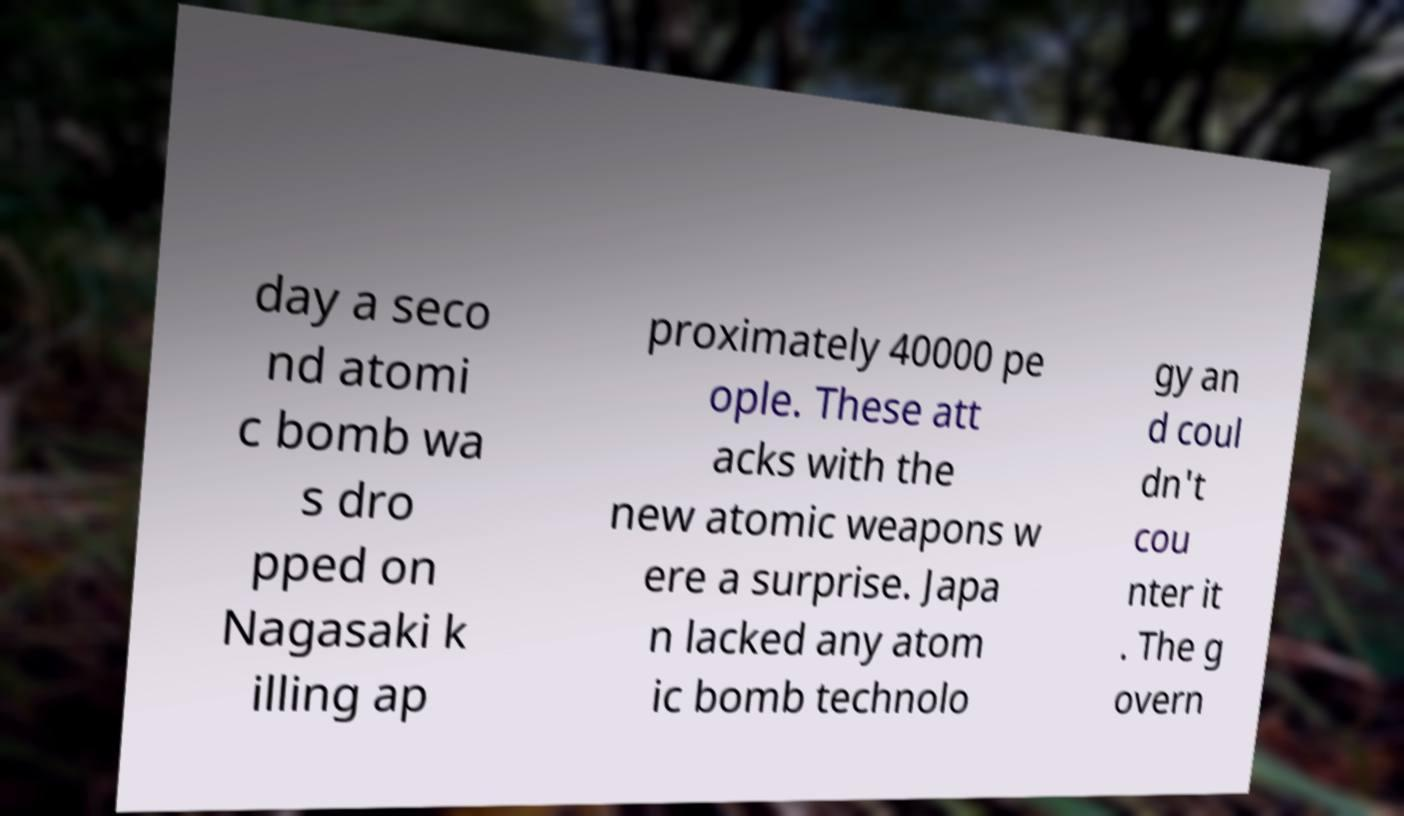Please read and relay the text visible in this image. What does it say? day a seco nd atomi c bomb wa s dro pped on Nagasaki k illing ap proximately 40000 pe ople. These att acks with the new atomic weapons w ere a surprise. Japa n lacked any atom ic bomb technolo gy an d coul dn't cou nter it . The g overn 